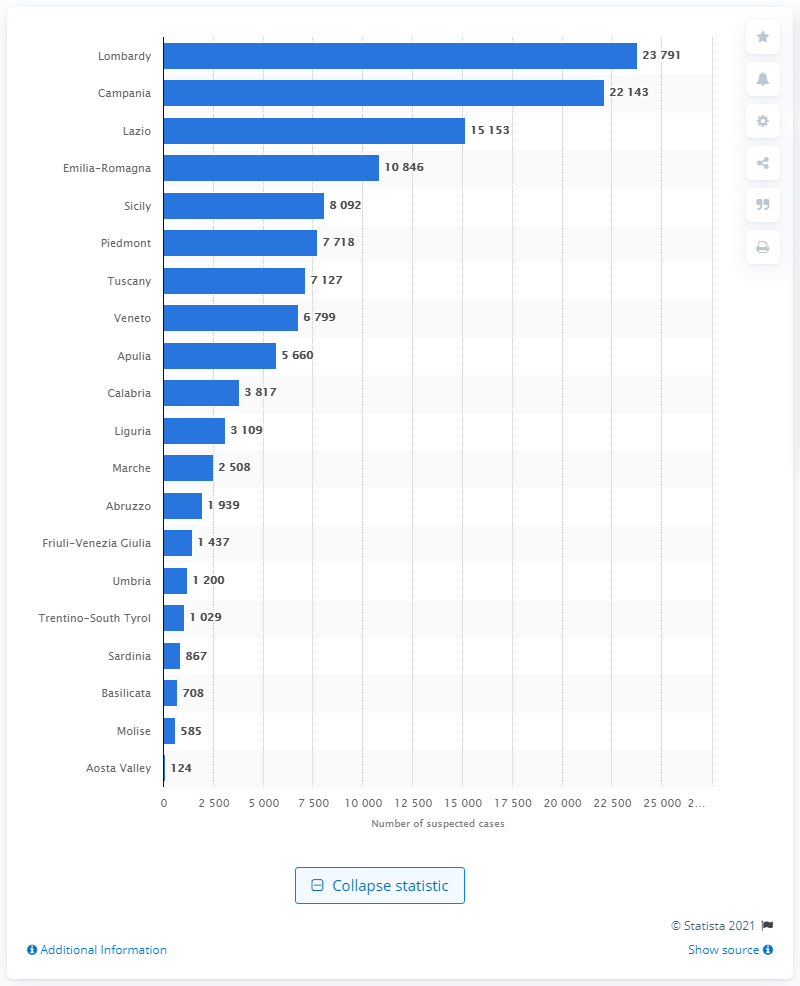Where was the largest number of suspected financial operations reported in Italy in 2019?
 Lombardy 